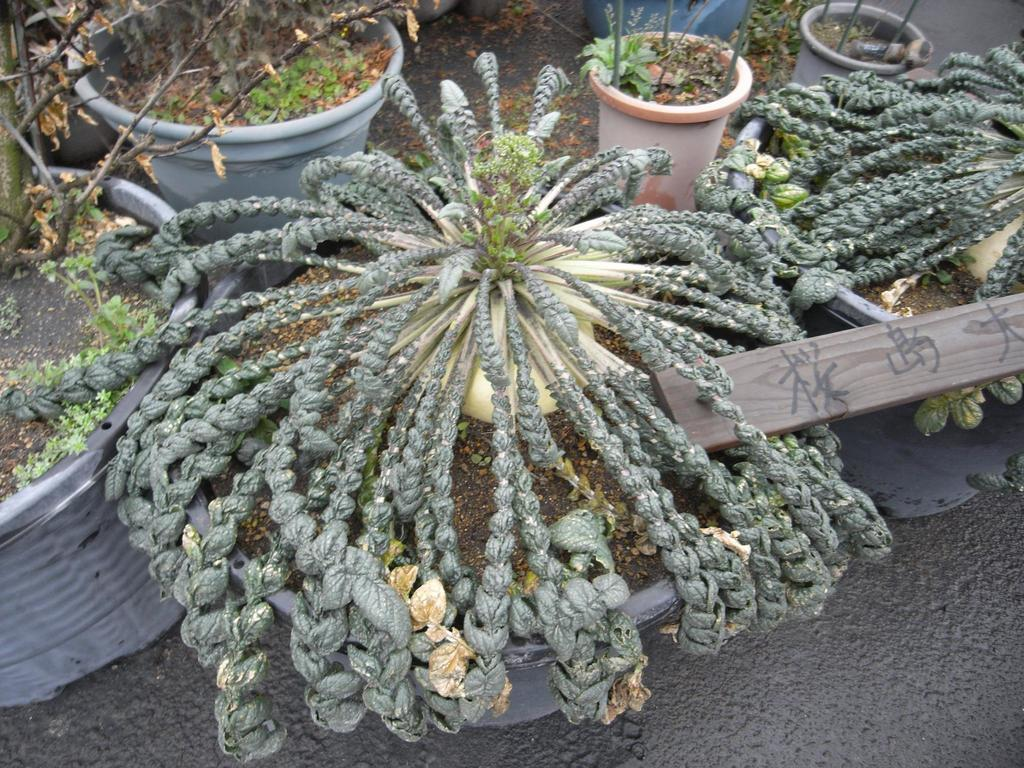What type of living organisms can be seen in the image? Plants can be seen in the image. How are the plants contained or supported in the image? The plants are placed in plant pots. Are the plant pots of the same size in the image? No, the plant pots are of different sizes in the image. Where are the plants and pots located in the image? The plants and pots are placed on the floor. What type of humor is being displayed by the nation in the image? There is no reference to humor or a nation in the image; it features plants in plant pots of different sizes placed on the floor. 